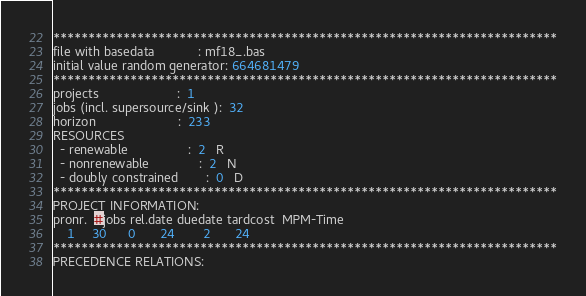<code> <loc_0><loc_0><loc_500><loc_500><_ObjectiveC_>************************************************************************
file with basedata            : mf18_.bas
initial value random generator: 664681479
************************************************************************
projects                      :  1
jobs (incl. supersource/sink ):  32
horizon                       :  233
RESOURCES
  - renewable                 :  2   R
  - nonrenewable              :  2   N
  - doubly constrained        :  0   D
************************************************************************
PROJECT INFORMATION:
pronr.  #jobs rel.date duedate tardcost  MPM-Time
    1     30      0       24        2       24
************************************************************************
PRECEDENCE RELATIONS:</code> 